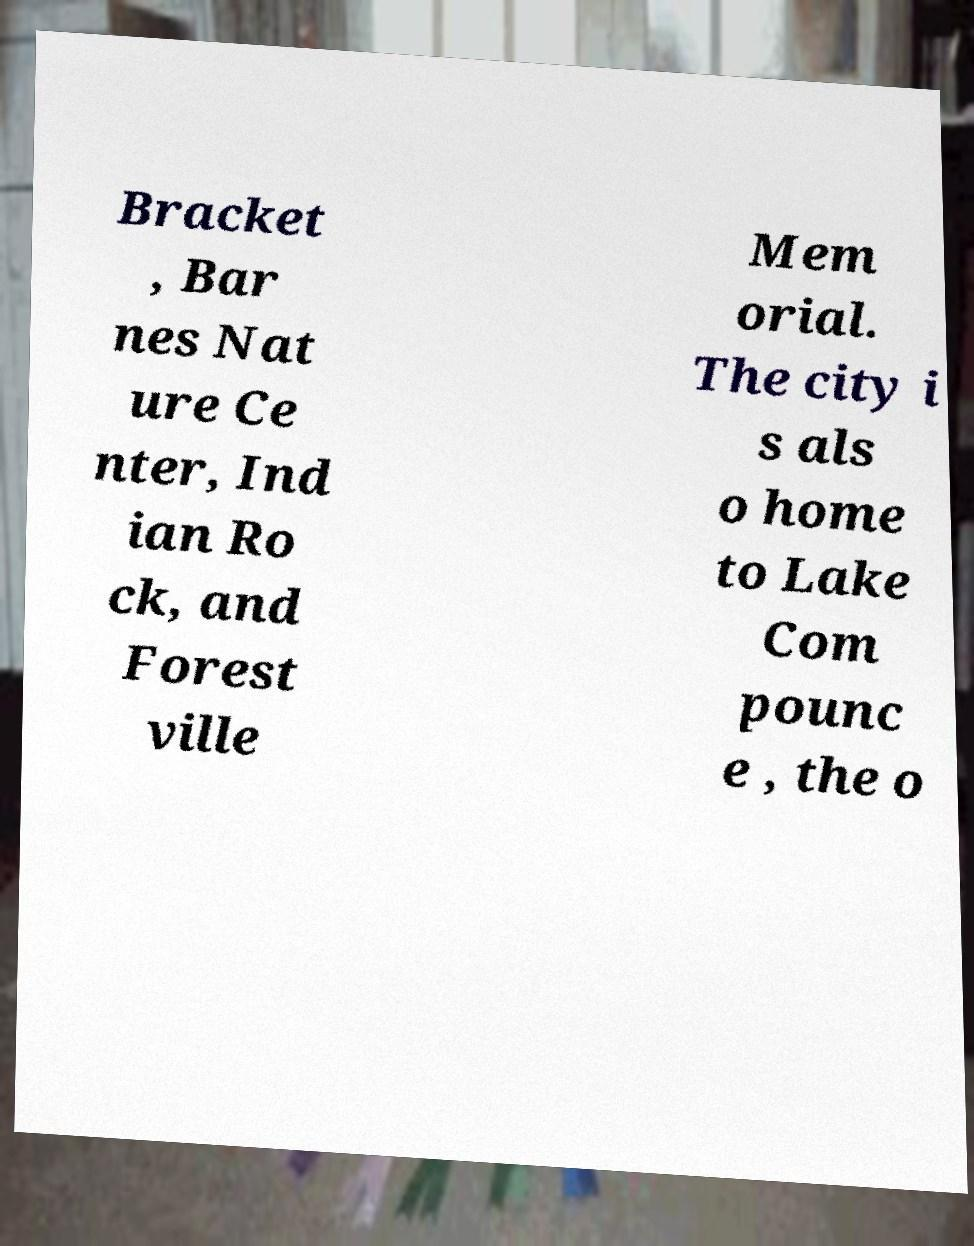Please read and relay the text visible in this image. What does it say? Bracket , Bar nes Nat ure Ce nter, Ind ian Ro ck, and Forest ville Mem orial. The city i s als o home to Lake Com pounc e , the o 